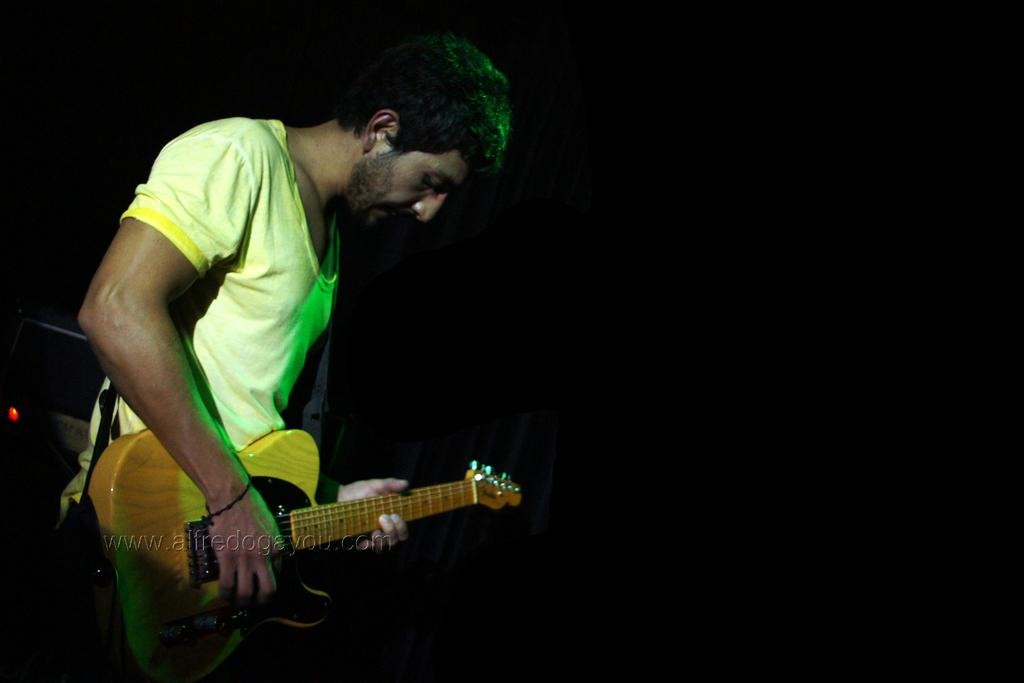What is the main subject of the image? The main subject of the image is a man. What is the man doing in the image? The man is standing and playing a guitar. What type of eggnog is the man drinking in the image? There is no eggnog present in the image; the man is playing a guitar. How does the man's voice sound while playing the guitar? The image does not provide any information about the man's voice, as it only shows him playing the guitar. 